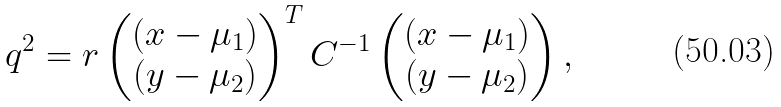<formula> <loc_0><loc_0><loc_500><loc_500>q ^ { 2 } = r \begin{pmatrix} \left ( x - \mu _ { 1 } \right ) \\ \left ( y - \mu _ { 2 } \right ) \end{pmatrix} ^ { T } C ^ { - 1 } \begin{pmatrix} \left ( x - \mu _ { 1 } \right ) \\ \left ( y - \mu _ { 2 } \right ) \end{pmatrix} ,</formula> 